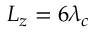<formula> <loc_0><loc_0><loc_500><loc_500>{ L _ { z } = 6 \lambda _ { c } }</formula> 